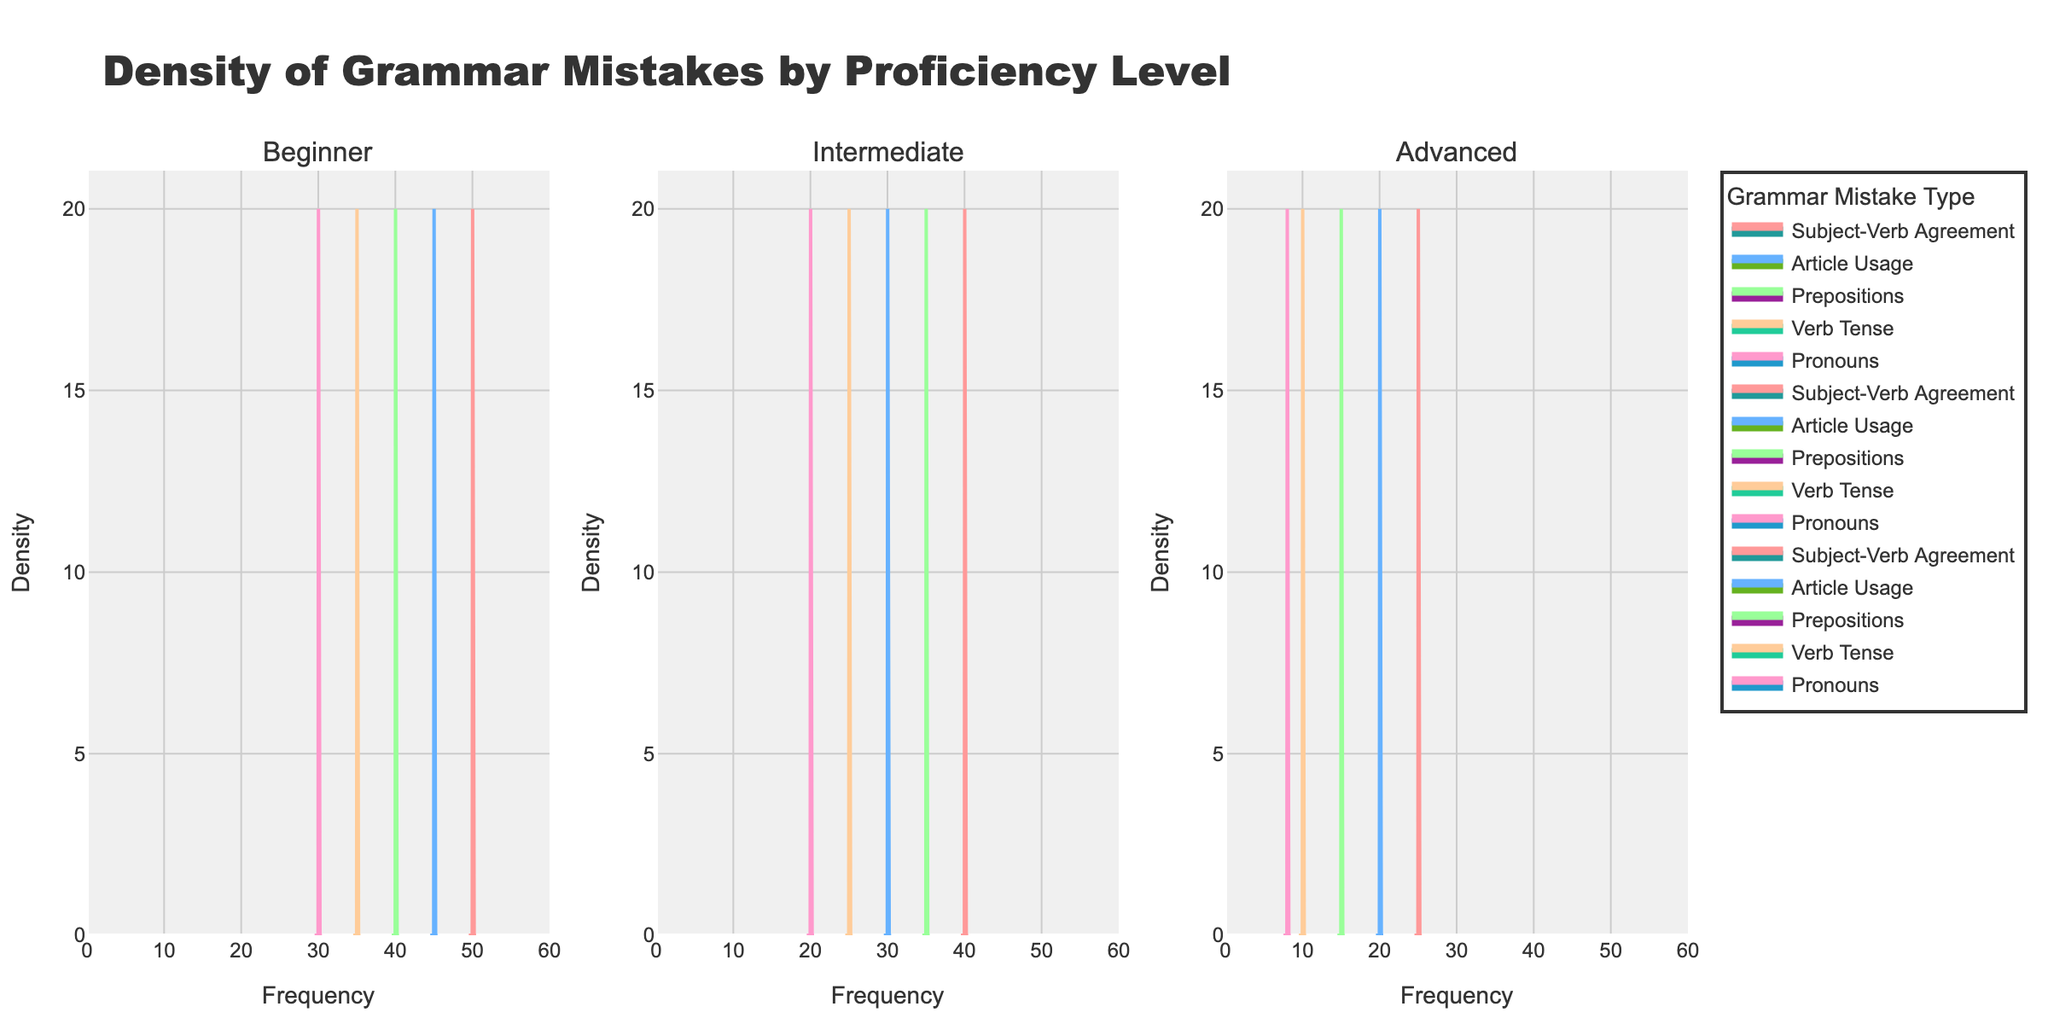What is the title of the plot? The title of the plot is written at the top. It reads "Density of Grammar Mistakes by Proficiency Level".
Answer: Density of Grammar Mistakes by Proficiency Level How many proficiency levels are shown in the plot? The subplot titles represent the proficiency levels. There are three subplots, indicating three proficiency levels: Beginner, Intermediate, and Advanced.
Answer: Three Which grammar mistake has the highest frequency in the Beginner proficiency level? In the subplot titled "Beginner," the peak of the density plot is highest for the "Subject-Verb Agreement" mistake, indicating it has the highest frequency.
Answer: Subject-Verb Agreement Compare the frequency of "Prepositions" mistakes between Beginner and Advanced proficiency levels. Which level shows a higher frequency? By observing the density peaks in both "Beginner" and "Advanced" subplots, the density plot for "Prepositions" has a higher peak in the Beginner subplot, indicating higher frequency.
Answer: Beginner What is the range of the x-axis in the plot? The x-axis in all subplots ranges from 0 to 60, as indicated by the ticks and the updated x-axis range.
Answer: 0 to 60 Which proficiency level exhibits the most variation in the density of "Article Usage" mistakes? By comparing the density plots for "Article Usage" across all subplots, the Beginner subplot shows the most variation, with the widest spread and highest peak.
Answer: Beginner Does the "Verb Tense" mistake type show a decreasing trend in frequency as proficiency level increases? Observing the density plots for "Verb Tense" across different proficiency levels, the frequency decreases: Beginner has the highest peak, followed by Intermediate, then Advanced.
Answer: Yes Which mistake type appears to consistently have the lowest frequency across all proficiency levels? By checking the lowest peaks in each subplot, "Pronouns" has the lowest frequency across Beginner, Intermediate, and Advanced levels.
Answer: Pronouns How does the frequency of "Subject-Verb Agreement" mistakes in the Intermediate proficiency level compare to Advanced? The density plot for "Subject-Verb Agreement" in the Intermediate subplot has a higher peak than the one in the Advanced subplot.
Answer: Higher in Intermediate What are the colors used for representing each grammar mistake type in the density plots? The colors for each mistake type are visible in the legend and density plots. Subject-Verb Agreement is pink, Article Usage is blue, Prepositions is green, Verb Tense is orange, and Pronouns is magenta.
Answer: Pink, Blue, Green, Orange, Magenta 